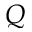Convert formula to latex. <formula><loc_0><loc_0><loc_500><loc_500>Q</formula> 